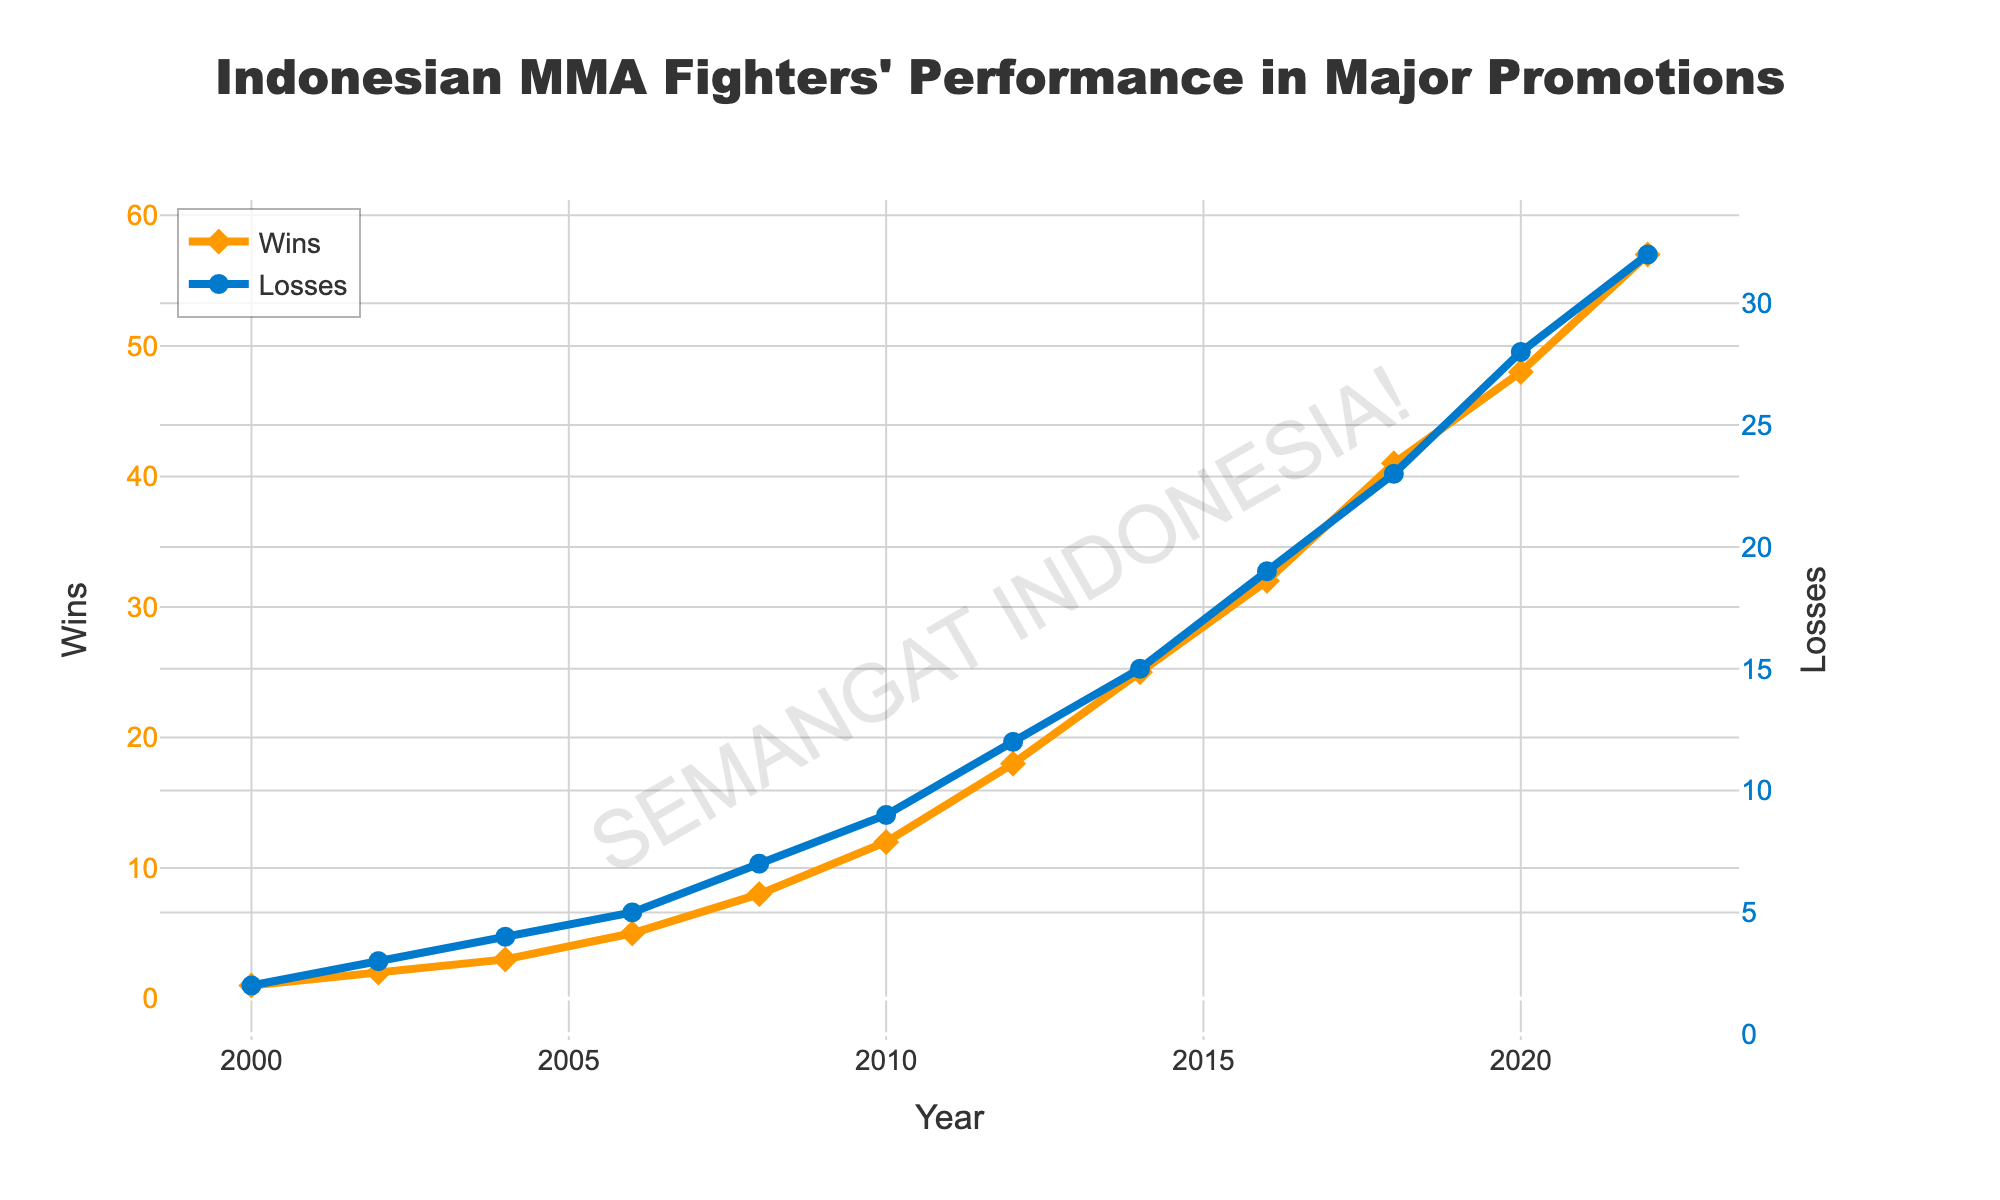What's the net win-loss record for Indonesian MMA fighters in 2014? To find the net win-loss record, subtract the number of losses from the number of wins for 2014. From the data, Wins = 25 and Losses = 15, so the net win-loss record is 25 - 15 = 10.
Answer: 10 Which year saw the highest number of wins for Indonesian MMA fighters? To find the year with the highest number of wins, locate the maximum value in the Wins series and note the corresponding year. The highest number of wins is 57 in 2022.
Answer: 2022 By how much did the wins increase from 2000 to 2022? To find the increase in wins, subtract the number of wins in 2000 from the number of wins in 2022. In 2000, Wins = 1; in 2022, Wins = 57. The increase is 57 - 1 = 56.
Answer: 56 In which year did the wins first exceed the losses? Examine the data to find the first year where the number of wins is greater than losses. This happened in 2008, where Wins = 8 and Losses = 7.
Answer: 2008 What was the average number of wins per year over the given period? To find the average, sum all the wins and divide by the number of years in the dataset. Total Wins = 1+2+3+5+8+12+18+25+32+41+48+57 = 252. The number of years = 12. The average is 252 / 12 = 21.
Answer: 21 Did the number of losses ever stay the same for consecutive data points? Check the Losses series to see if any value repeats consecutively. There is no such instance in the data provided.
Answer: No By what percentage did the number of wins increase from 2010 to 2016? Calculate the percentage increase using the formula: \[((Wins_{2016} - Wins_{2010}) / Wins_{2010}) * 100]\]. For 2010, Wins = 12, and for 2016, Wins = 32. Therefore, \[((32 - 12) / 12) * 100 = (20 / 12) * 100 \approx 166.67\%\].
Answer: 166.67% In which year did the difference between wins and losses penultimate increase sharply? The penultimate year difference between wins and losses is essentially the second last data point, compare 2018 and 2020. In 2018, Wins - Losses = 41 - 23 = 18. In 2020, Wins - Losses = 48 - 28 = 20. The increase from 2 units of difference.
Answer: 2020 